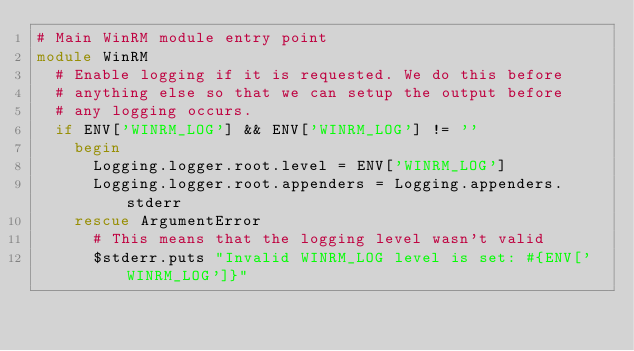<code> <loc_0><loc_0><loc_500><loc_500><_Ruby_># Main WinRM module entry point
module WinRM
  # Enable logging if it is requested. We do this before
  # anything else so that we can setup the output before
  # any logging occurs.
  if ENV['WINRM_LOG'] && ENV['WINRM_LOG'] != ''
    begin
      Logging.logger.root.level = ENV['WINRM_LOG']
      Logging.logger.root.appenders = Logging.appenders.stderr
    rescue ArgumentError
      # This means that the logging level wasn't valid
      $stderr.puts "Invalid WINRM_LOG level is set: #{ENV['WINRM_LOG']}"</code> 